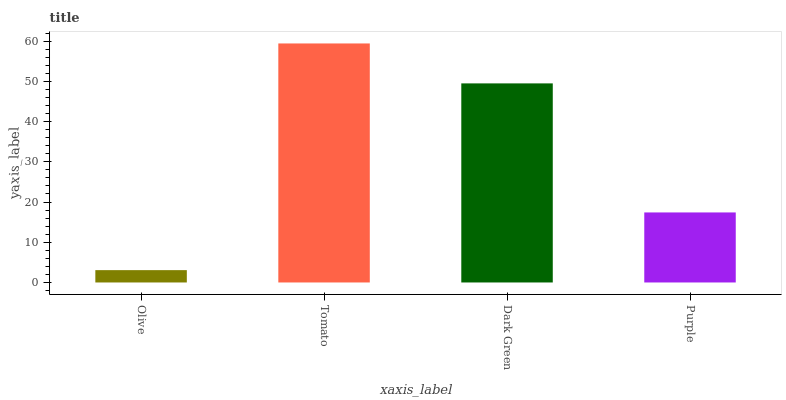Is Dark Green the minimum?
Answer yes or no. No. Is Dark Green the maximum?
Answer yes or no. No. Is Tomato greater than Dark Green?
Answer yes or no. Yes. Is Dark Green less than Tomato?
Answer yes or no. Yes. Is Dark Green greater than Tomato?
Answer yes or no. No. Is Tomato less than Dark Green?
Answer yes or no. No. Is Dark Green the high median?
Answer yes or no. Yes. Is Purple the low median?
Answer yes or no. Yes. Is Olive the high median?
Answer yes or no. No. Is Olive the low median?
Answer yes or no. No. 